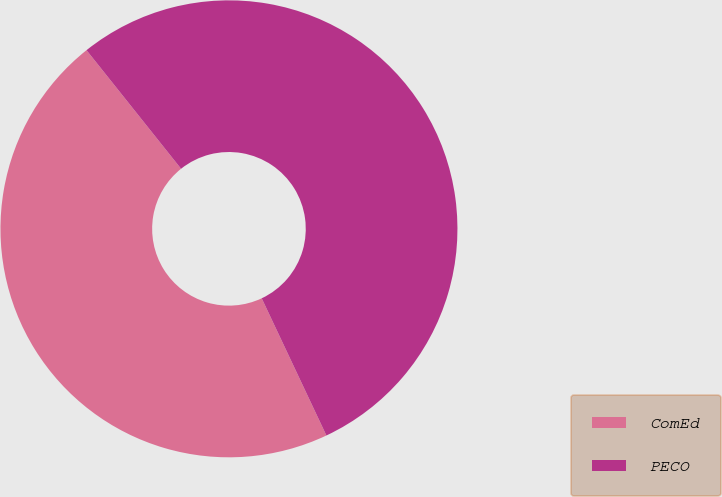Convert chart. <chart><loc_0><loc_0><loc_500><loc_500><pie_chart><fcel>ComEd<fcel>PECO<nl><fcel>46.3%<fcel>53.7%<nl></chart> 